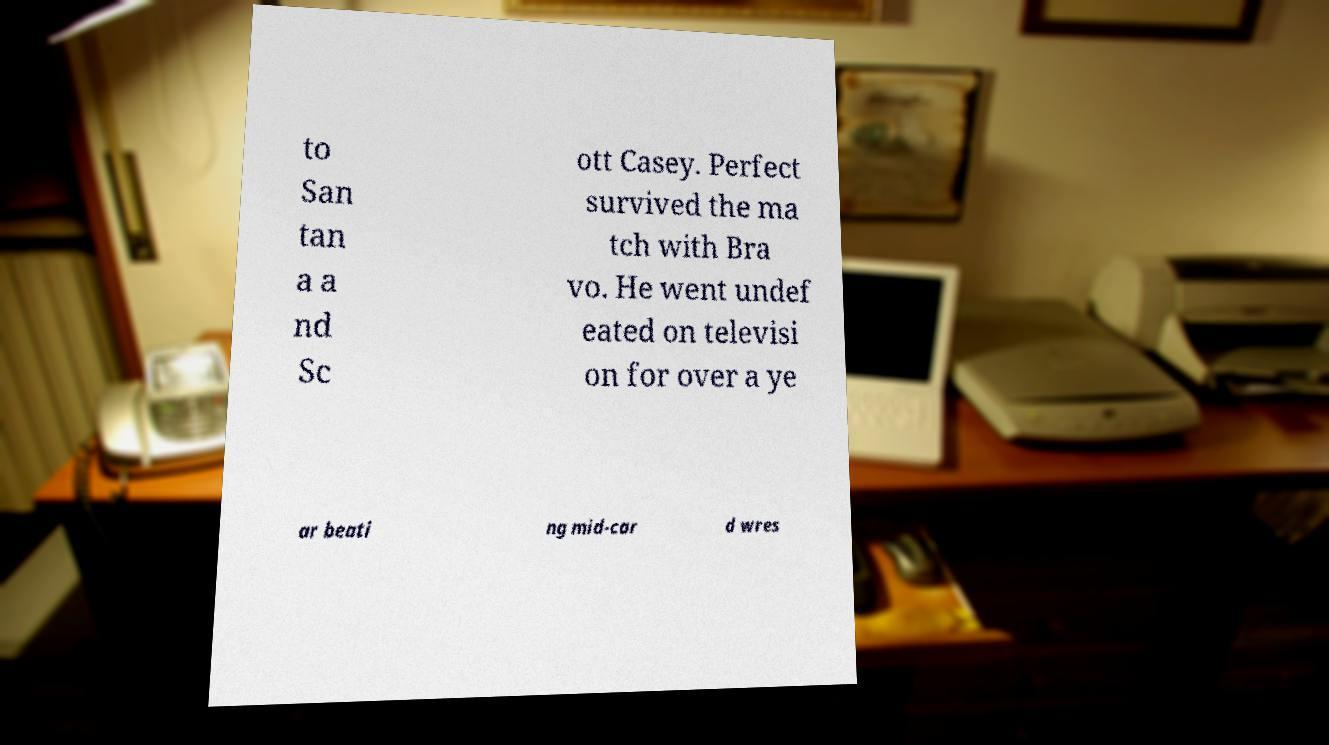Can you accurately transcribe the text from the provided image for me? to San tan a a nd Sc ott Casey. Perfect survived the ma tch with Bra vo. He went undef eated on televisi on for over a ye ar beati ng mid-car d wres 